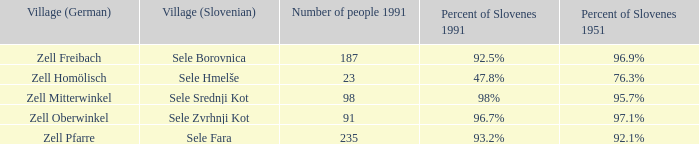Name all the german settlements with 7 Zell Homölisch. 